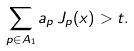<formula> <loc_0><loc_0><loc_500><loc_500>\sum _ { p \in A _ { 1 } } a _ { p } \, { J } _ { p } ( x ) > t .</formula> 